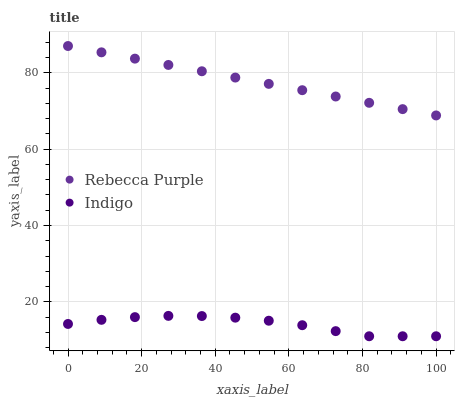Does Indigo have the minimum area under the curve?
Answer yes or no. Yes. Does Rebecca Purple have the maximum area under the curve?
Answer yes or no. Yes. Does Rebecca Purple have the minimum area under the curve?
Answer yes or no. No. Is Rebecca Purple the smoothest?
Answer yes or no. Yes. Is Indigo the roughest?
Answer yes or no. Yes. Is Rebecca Purple the roughest?
Answer yes or no. No. Does Indigo have the lowest value?
Answer yes or no. Yes. Does Rebecca Purple have the lowest value?
Answer yes or no. No. Does Rebecca Purple have the highest value?
Answer yes or no. Yes. Is Indigo less than Rebecca Purple?
Answer yes or no. Yes. Is Rebecca Purple greater than Indigo?
Answer yes or no. Yes. Does Indigo intersect Rebecca Purple?
Answer yes or no. No. 